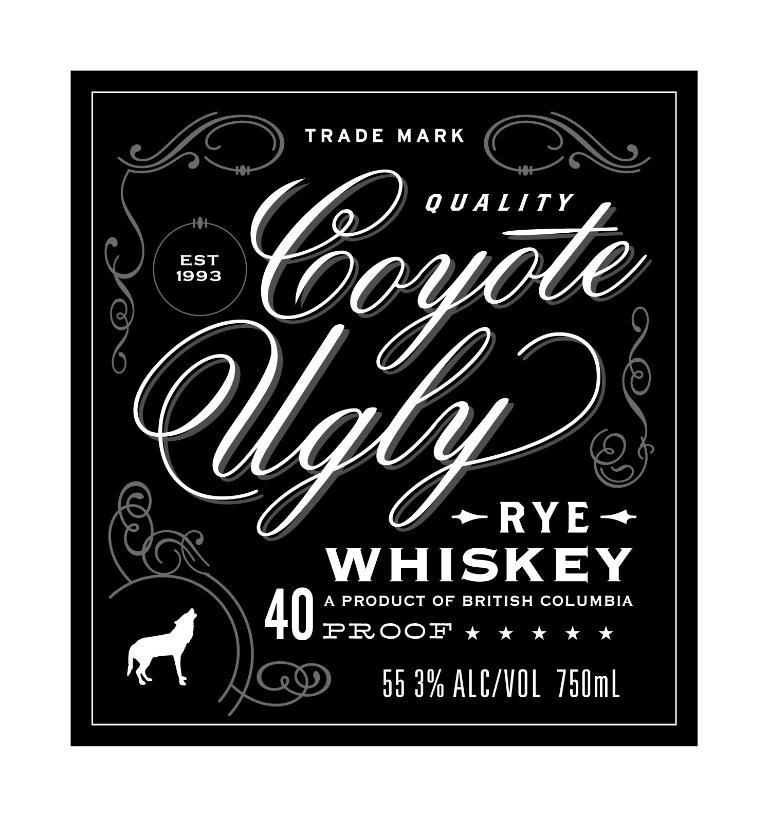<image>
Render a clear and concise summary of the photo. Poster for RYE whiskye which is 750 mL. 